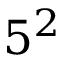Convert formula to latex. <formula><loc_0><loc_0><loc_500><loc_500>5 ^ { 2 }</formula> 